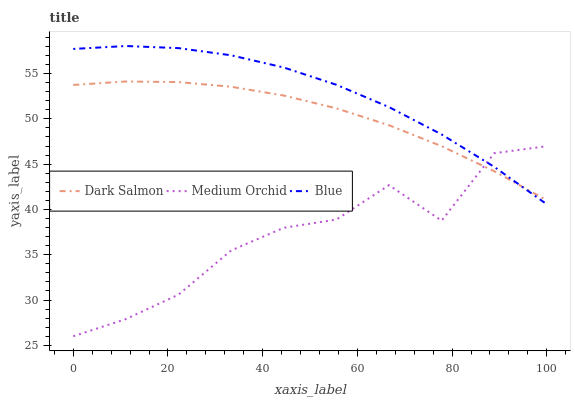Does Medium Orchid have the minimum area under the curve?
Answer yes or no. Yes. Does Blue have the maximum area under the curve?
Answer yes or no. Yes. Does Dark Salmon have the minimum area under the curve?
Answer yes or no. No. Does Dark Salmon have the maximum area under the curve?
Answer yes or no. No. Is Dark Salmon the smoothest?
Answer yes or no. Yes. Is Medium Orchid the roughest?
Answer yes or no. Yes. Is Medium Orchid the smoothest?
Answer yes or no. No. Is Dark Salmon the roughest?
Answer yes or no. No. Does Dark Salmon have the lowest value?
Answer yes or no. No. Does Dark Salmon have the highest value?
Answer yes or no. No. 